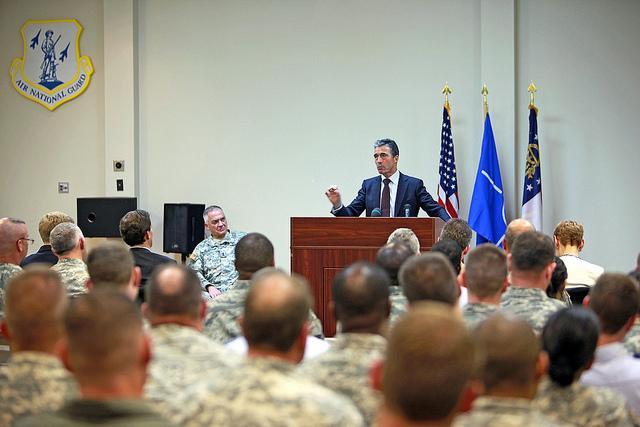What type of uniforms are some of the men wearing?
Short answer required. Army. Is the speaker boring?
Concise answer only. No. How many flags are there?
Quick response, please. 3. What likely branch of military are the men in the audience?
Short answer required. Army. 